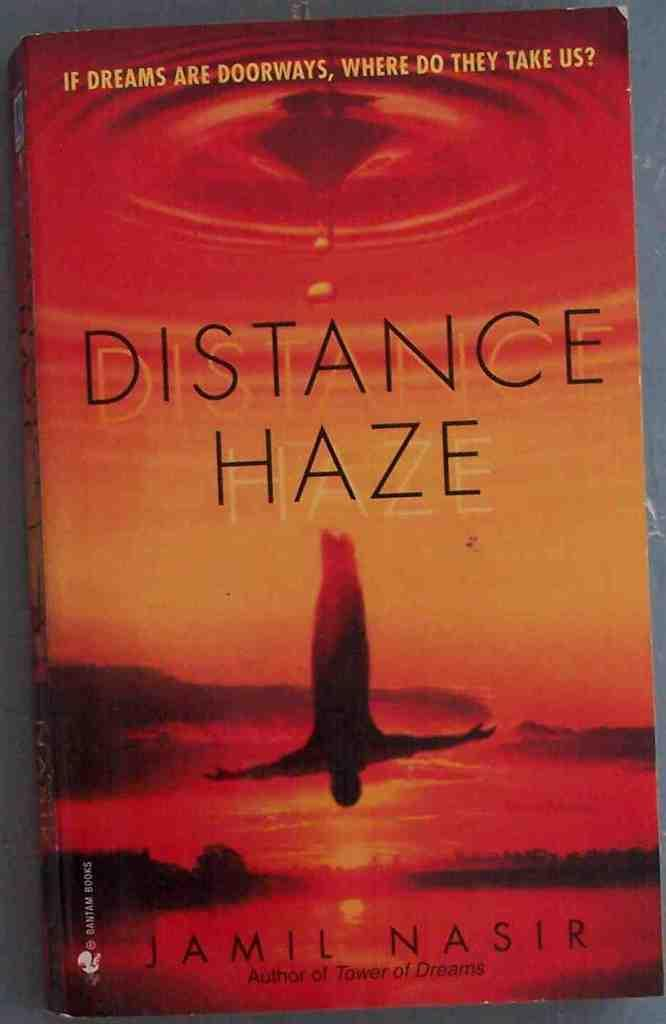<image>
Relay a brief, clear account of the picture shown. An orange and red book cover titled Distance Haze. 